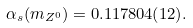Convert formula to latex. <formula><loc_0><loc_0><loc_500><loc_500>\alpha _ { s } ( m _ { Z ^ { 0 } } ) = 0 . 1 1 7 8 0 4 ( 1 2 ) .</formula> 